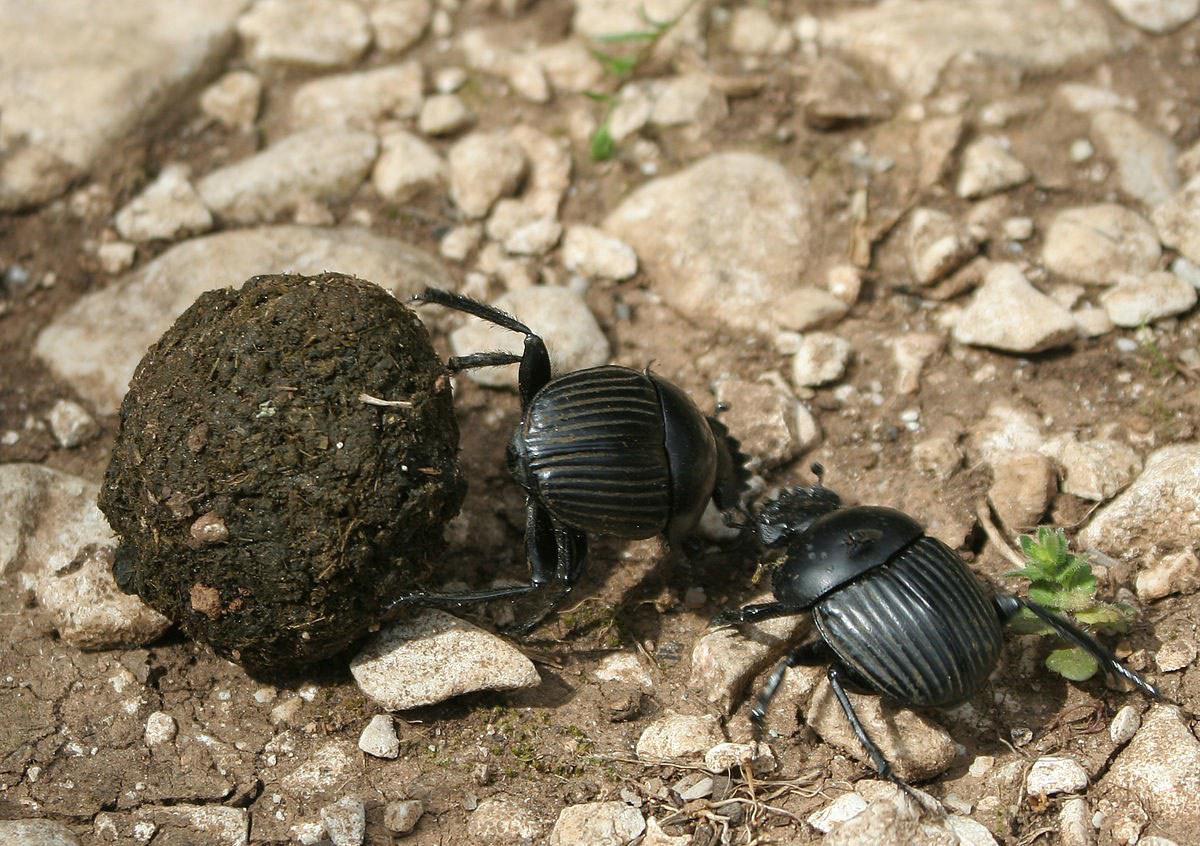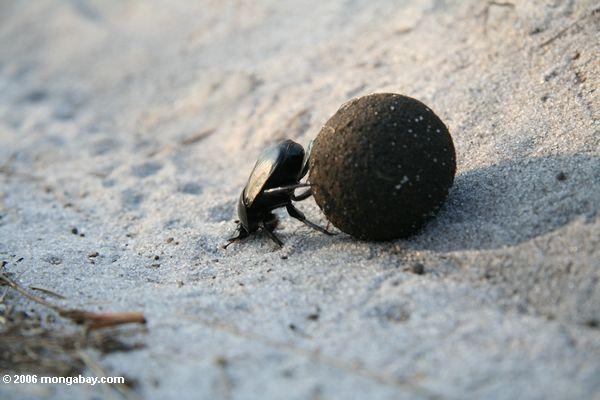The first image is the image on the left, the second image is the image on the right. Considering the images on both sides, is "The right image has a beetle crawling on a persons hand." valid? Answer yes or no. No. The first image is the image on the left, the second image is the image on the right. For the images shown, is this caption "A beetle crawls on a persons hand in the image on the right." true? Answer yes or no. No. 